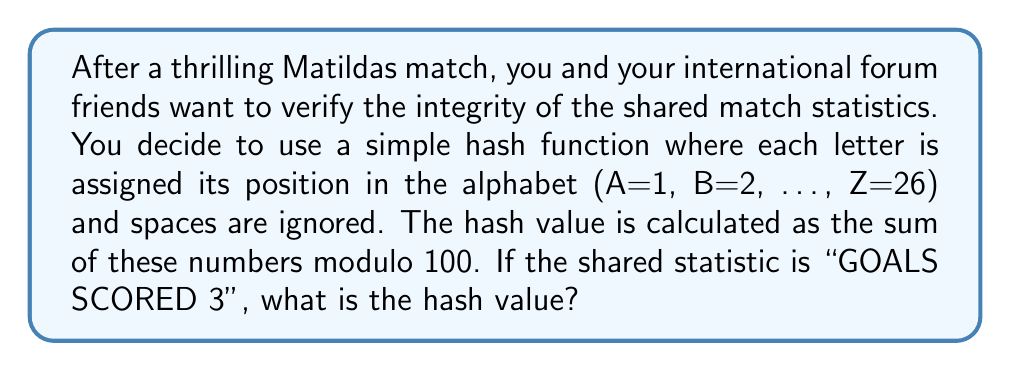Give your solution to this math problem. Let's break this down step-by-step:

1) First, we assign numbers to each letter:
   G = 7, O = 15, A = 1, L = 12, S = 19
   S = 19, C = 3, O = 15, R = 18, E = 5, D = 4
   3 = 3 (we keep numbers as they are)

2) Now, we sum these numbers:
   $$ 7 + 15 + 1 + 12 + 19 + 19 + 3 + 15 + 18 + 5 + 4 + 3 = 121 $$

3) The hash function takes this sum modulo 100:
   $$ 121 \mod 100 = 21 $$

Therefore, the hash value is 21.

This hash can be used to quickly verify if the statistic has been altered. If someone changes the statistic, the hash value will likely be different, alerting you to potential tampering.
Answer: 21 